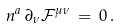<formula> <loc_0><loc_0><loc_500><loc_500>n ^ { a } \, \partial _ { \nu } \mathcal { F } ^ { \mu \nu } \, = \, 0 \, .</formula> 